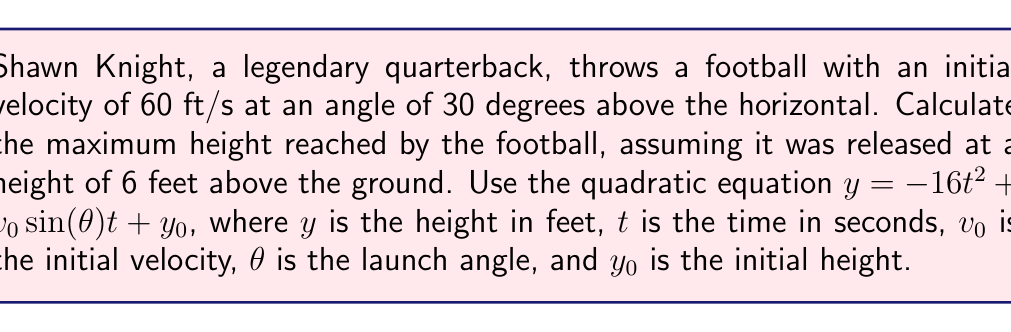Can you solve this math problem? 1) First, let's identify the given values:
   $v_0 = 60$ ft/s
   $\theta = 30°$
   $y_0 = 6$ ft

2) We need to use the equation: $y = -16t^2 + v_0\sin(\theta)t + y_0$

3) Substitute the known values:
   $y = -16t^2 + 60\sin(30°)t + 6$

4) Simplify $\sin(30°)$:
   $\sin(30°) = 0.5$
   $y = -16t^2 + 60(0.5)t + 6$
   $y = -16t^2 + 30t + 6$

5) To find the maximum height, we need to find the vertex of this parabola. The t-coordinate of the vertex is given by $t = -\frac{b}{2a}$ where $a$ and $b$ are the coefficients of $t^2$ and $t$ respectively.

6) Calculate $t$ at the maximum height:
   $t = -\frac{30}{2(-16)} = \frac{30}{32} = 0.9375$ seconds

7) Now substitute this $t$ value back into our equation to find the maximum height:
   $y = -16(0.9375)^2 + 30(0.9375) + 6$
   $y = -14.0625 + 28.125 + 6$
   $y = 20.0625$ ft

8) The maximum height is 20.0625 ft above the ground.
Answer: 20.0625 ft 